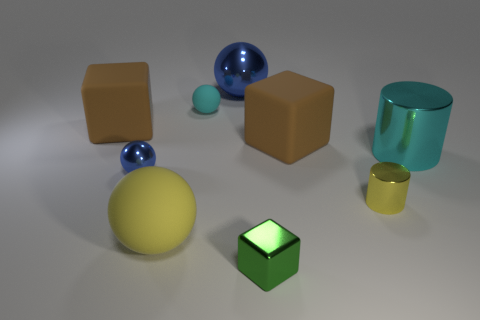Subtract all brown matte cubes. How many cubes are left? 1 Subtract 1 blocks. How many blocks are left? 2 Subtract all yellow spheres. How many spheres are left? 3 Add 1 blue objects. How many objects exist? 10 Subtract all gray balls. Subtract all cyan blocks. How many balls are left? 4 Subtract all balls. How many objects are left? 5 Add 6 big matte objects. How many big matte objects exist? 9 Subtract 0 brown cylinders. How many objects are left? 9 Subtract all tiny green metal blocks. Subtract all small matte objects. How many objects are left? 7 Add 4 cyan things. How many cyan things are left? 6 